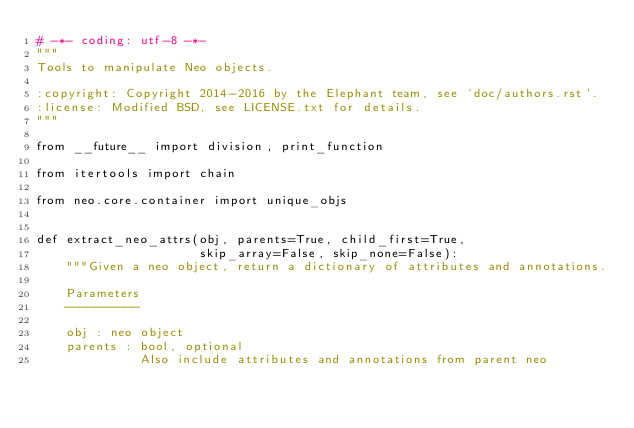Convert code to text. <code><loc_0><loc_0><loc_500><loc_500><_Python_># -*- coding: utf-8 -*-
"""
Tools to manipulate Neo objects.

:copyright: Copyright 2014-2016 by the Elephant team, see `doc/authors.rst`.
:license: Modified BSD, see LICENSE.txt for details.
"""

from __future__ import division, print_function

from itertools import chain

from neo.core.container import unique_objs


def extract_neo_attrs(obj, parents=True, child_first=True,
                      skip_array=False, skip_none=False):
    """Given a neo object, return a dictionary of attributes and annotations.

    Parameters
    ----------

    obj : neo object
    parents : bool, optional
              Also include attributes and annotations from parent neo</code> 